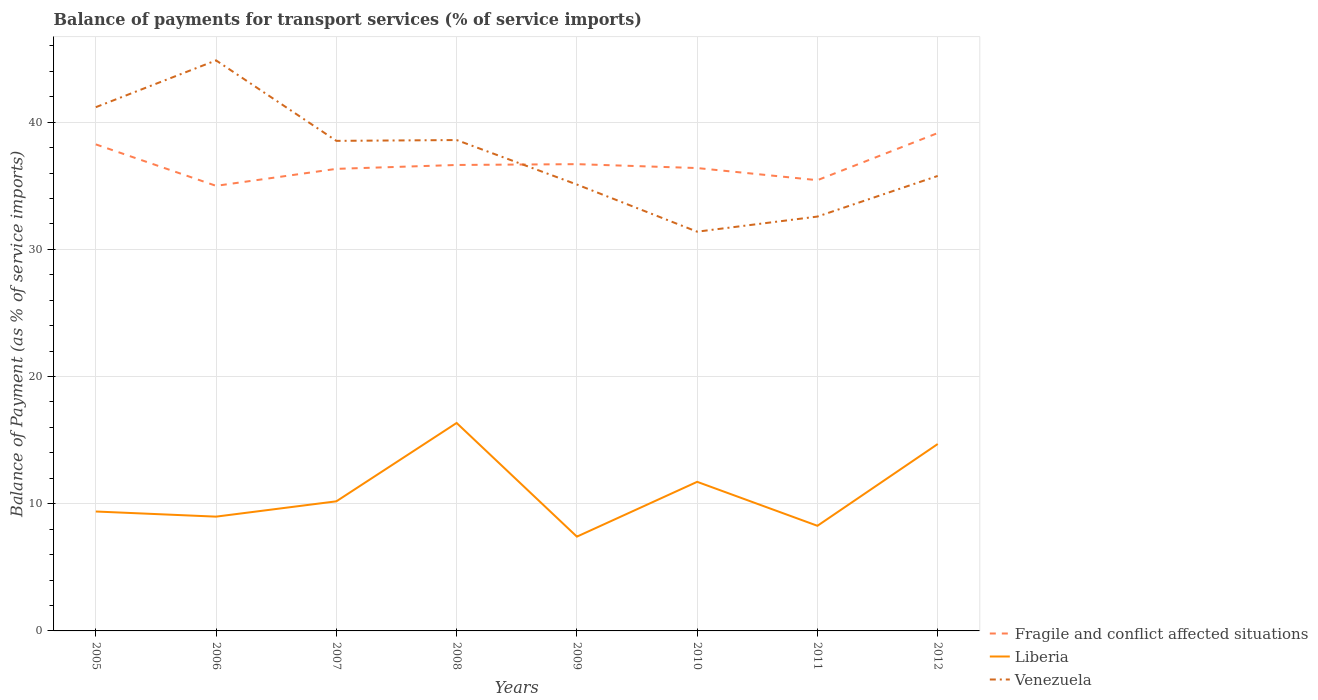How many different coloured lines are there?
Your answer should be compact. 3. Across all years, what is the maximum balance of payments for transport services in Fragile and conflict affected situations?
Give a very brief answer. 34.99. What is the total balance of payments for transport services in Liberia in the graph?
Ensure brevity in your answer.  4.63. What is the difference between the highest and the second highest balance of payments for transport services in Fragile and conflict affected situations?
Keep it short and to the point. 4.15. What is the difference between the highest and the lowest balance of payments for transport services in Liberia?
Provide a short and direct response. 3. Is the balance of payments for transport services in Liberia strictly greater than the balance of payments for transport services in Fragile and conflict affected situations over the years?
Your answer should be very brief. Yes. Are the values on the major ticks of Y-axis written in scientific E-notation?
Provide a succinct answer. No. Does the graph contain any zero values?
Your answer should be compact. No. Where does the legend appear in the graph?
Provide a succinct answer. Bottom right. How many legend labels are there?
Provide a short and direct response. 3. What is the title of the graph?
Keep it short and to the point. Balance of payments for transport services (% of service imports). Does "Uzbekistan" appear as one of the legend labels in the graph?
Make the answer very short. No. What is the label or title of the X-axis?
Offer a very short reply. Years. What is the label or title of the Y-axis?
Offer a terse response. Balance of Payment (as % of service imports). What is the Balance of Payment (as % of service imports) in Fragile and conflict affected situations in 2005?
Provide a short and direct response. 38.25. What is the Balance of Payment (as % of service imports) in Liberia in 2005?
Make the answer very short. 9.39. What is the Balance of Payment (as % of service imports) of Venezuela in 2005?
Keep it short and to the point. 41.18. What is the Balance of Payment (as % of service imports) in Fragile and conflict affected situations in 2006?
Your answer should be very brief. 34.99. What is the Balance of Payment (as % of service imports) of Liberia in 2006?
Offer a terse response. 8.99. What is the Balance of Payment (as % of service imports) in Venezuela in 2006?
Your answer should be compact. 44.86. What is the Balance of Payment (as % of service imports) of Fragile and conflict affected situations in 2007?
Ensure brevity in your answer.  36.33. What is the Balance of Payment (as % of service imports) of Liberia in 2007?
Your answer should be very brief. 10.19. What is the Balance of Payment (as % of service imports) in Venezuela in 2007?
Offer a terse response. 38.53. What is the Balance of Payment (as % of service imports) in Fragile and conflict affected situations in 2008?
Keep it short and to the point. 36.64. What is the Balance of Payment (as % of service imports) of Liberia in 2008?
Provide a succinct answer. 16.35. What is the Balance of Payment (as % of service imports) in Venezuela in 2008?
Offer a terse response. 38.59. What is the Balance of Payment (as % of service imports) in Fragile and conflict affected situations in 2009?
Offer a very short reply. 36.7. What is the Balance of Payment (as % of service imports) in Liberia in 2009?
Your response must be concise. 7.41. What is the Balance of Payment (as % of service imports) of Venezuela in 2009?
Offer a very short reply. 35.1. What is the Balance of Payment (as % of service imports) of Fragile and conflict affected situations in 2010?
Keep it short and to the point. 36.39. What is the Balance of Payment (as % of service imports) in Liberia in 2010?
Offer a very short reply. 11.72. What is the Balance of Payment (as % of service imports) in Venezuela in 2010?
Ensure brevity in your answer.  31.39. What is the Balance of Payment (as % of service imports) in Fragile and conflict affected situations in 2011?
Keep it short and to the point. 35.44. What is the Balance of Payment (as % of service imports) of Liberia in 2011?
Your answer should be compact. 8.27. What is the Balance of Payment (as % of service imports) in Venezuela in 2011?
Make the answer very short. 32.58. What is the Balance of Payment (as % of service imports) of Fragile and conflict affected situations in 2012?
Provide a short and direct response. 39.15. What is the Balance of Payment (as % of service imports) of Liberia in 2012?
Provide a short and direct response. 14.7. What is the Balance of Payment (as % of service imports) in Venezuela in 2012?
Ensure brevity in your answer.  35.77. Across all years, what is the maximum Balance of Payment (as % of service imports) of Fragile and conflict affected situations?
Your answer should be compact. 39.15. Across all years, what is the maximum Balance of Payment (as % of service imports) in Liberia?
Make the answer very short. 16.35. Across all years, what is the maximum Balance of Payment (as % of service imports) of Venezuela?
Your answer should be very brief. 44.86. Across all years, what is the minimum Balance of Payment (as % of service imports) of Fragile and conflict affected situations?
Your response must be concise. 34.99. Across all years, what is the minimum Balance of Payment (as % of service imports) in Liberia?
Your answer should be very brief. 7.41. Across all years, what is the minimum Balance of Payment (as % of service imports) in Venezuela?
Provide a succinct answer. 31.39. What is the total Balance of Payment (as % of service imports) in Fragile and conflict affected situations in the graph?
Your answer should be compact. 293.89. What is the total Balance of Payment (as % of service imports) in Liberia in the graph?
Give a very brief answer. 87.01. What is the total Balance of Payment (as % of service imports) in Venezuela in the graph?
Give a very brief answer. 298. What is the difference between the Balance of Payment (as % of service imports) of Fragile and conflict affected situations in 2005 and that in 2006?
Keep it short and to the point. 3.26. What is the difference between the Balance of Payment (as % of service imports) of Liberia in 2005 and that in 2006?
Provide a short and direct response. 0.4. What is the difference between the Balance of Payment (as % of service imports) of Venezuela in 2005 and that in 2006?
Your answer should be compact. -3.68. What is the difference between the Balance of Payment (as % of service imports) of Fragile and conflict affected situations in 2005 and that in 2007?
Offer a very short reply. 1.92. What is the difference between the Balance of Payment (as % of service imports) in Liberia in 2005 and that in 2007?
Your answer should be compact. -0.8. What is the difference between the Balance of Payment (as % of service imports) in Venezuela in 2005 and that in 2007?
Your answer should be compact. 2.65. What is the difference between the Balance of Payment (as % of service imports) in Fragile and conflict affected situations in 2005 and that in 2008?
Your answer should be compact. 1.62. What is the difference between the Balance of Payment (as % of service imports) in Liberia in 2005 and that in 2008?
Your answer should be compact. -6.96. What is the difference between the Balance of Payment (as % of service imports) in Venezuela in 2005 and that in 2008?
Offer a very short reply. 2.58. What is the difference between the Balance of Payment (as % of service imports) in Fragile and conflict affected situations in 2005 and that in 2009?
Give a very brief answer. 1.55. What is the difference between the Balance of Payment (as % of service imports) of Liberia in 2005 and that in 2009?
Your answer should be very brief. 1.98. What is the difference between the Balance of Payment (as % of service imports) of Venezuela in 2005 and that in 2009?
Give a very brief answer. 6.08. What is the difference between the Balance of Payment (as % of service imports) in Fragile and conflict affected situations in 2005 and that in 2010?
Your response must be concise. 1.86. What is the difference between the Balance of Payment (as % of service imports) of Liberia in 2005 and that in 2010?
Make the answer very short. -2.33. What is the difference between the Balance of Payment (as % of service imports) of Venezuela in 2005 and that in 2010?
Make the answer very short. 9.79. What is the difference between the Balance of Payment (as % of service imports) of Fragile and conflict affected situations in 2005 and that in 2011?
Your answer should be compact. 2.81. What is the difference between the Balance of Payment (as % of service imports) in Liberia in 2005 and that in 2011?
Your response must be concise. 1.12. What is the difference between the Balance of Payment (as % of service imports) in Venezuela in 2005 and that in 2011?
Give a very brief answer. 8.6. What is the difference between the Balance of Payment (as % of service imports) of Fragile and conflict affected situations in 2005 and that in 2012?
Your response must be concise. -0.89. What is the difference between the Balance of Payment (as % of service imports) of Liberia in 2005 and that in 2012?
Your response must be concise. -5.31. What is the difference between the Balance of Payment (as % of service imports) of Venezuela in 2005 and that in 2012?
Offer a terse response. 5.41. What is the difference between the Balance of Payment (as % of service imports) in Fragile and conflict affected situations in 2006 and that in 2007?
Your answer should be compact. -1.33. What is the difference between the Balance of Payment (as % of service imports) of Liberia in 2006 and that in 2007?
Give a very brief answer. -1.2. What is the difference between the Balance of Payment (as % of service imports) of Venezuela in 2006 and that in 2007?
Provide a short and direct response. 6.33. What is the difference between the Balance of Payment (as % of service imports) of Fragile and conflict affected situations in 2006 and that in 2008?
Offer a terse response. -1.64. What is the difference between the Balance of Payment (as % of service imports) in Liberia in 2006 and that in 2008?
Provide a succinct answer. -7.37. What is the difference between the Balance of Payment (as % of service imports) in Venezuela in 2006 and that in 2008?
Provide a succinct answer. 6.26. What is the difference between the Balance of Payment (as % of service imports) of Fragile and conflict affected situations in 2006 and that in 2009?
Offer a terse response. -1.71. What is the difference between the Balance of Payment (as % of service imports) of Liberia in 2006 and that in 2009?
Keep it short and to the point. 1.57. What is the difference between the Balance of Payment (as % of service imports) of Venezuela in 2006 and that in 2009?
Offer a terse response. 9.76. What is the difference between the Balance of Payment (as % of service imports) of Fragile and conflict affected situations in 2006 and that in 2010?
Your response must be concise. -1.4. What is the difference between the Balance of Payment (as % of service imports) in Liberia in 2006 and that in 2010?
Offer a very short reply. -2.74. What is the difference between the Balance of Payment (as % of service imports) of Venezuela in 2006 and that in 2010?
Your response must be concise. 13.47. What is the difference between the Balance of Payment (as % of service imports) in Fragile and conflict affected situations in 2006 and that in 2011?
Ensure brevity in your answer.  -0.45. What is the difference between the Balance of Payment (as % of service imports) in Liberia in 2006 and that in 2011?
Your answer should be compact. 0.72. What is the difference between the Balance of Payment (as % of service imports) of Venezuela in 2006 and that in 2011?
Your answer should be very brief. 12.28. What is the difference between the Balance of Payment (as % of service imports) of Fragile and conflict affected situations in 2006 and that in 2012?
Offer a terse response. -4.15. What is the difference between the Balance of Payment (as % of service imports) of Liberia in 2006 and that in 2012?
Keep it short and to the point. -5.71. What is the difference between the Balance of Payment (as % of service imports) of Venezuela in 2006 and that in 2012?
Provide a short and direct response. 9.08. What is the difference between the Balance of Payment (as % of service imports) in Fragile and conflict affected situations in 2007 and that in 2008?
Your answer should be very brief. -0.31. What is the difference between the Balance of Payment (as % of service imports) in Liberia in 2007 and that in 2008?
Provide a short and direct response. -6.16. What is the difference between the Balance of Payment (as % of service imports) in Venezuela in 2007 and that in 2008?
Give a very brief answer. -0.06. What is the difference between the Balance of Payment (as % of service imports) of Fragile and conflict affected situations in 2007 and that in 2009?
Give a very brief answer. -0.37. What is the difference between the Balance of Payment (as % of service imports) of Liberia in 2007 and that in 2009?
Make the answer very short. 2.78. What is the difference between the Balance of Payment (as % of service imports) of Venezuela in 2007 and that in 2009?
Ensure brevity in your answer.  3.43. What is the difference between the Balance of Payment (as % of service imports) in Fragile and conflict affected situations in 2007 and that in 2010?
Offer a terse response. -0.06. What is the difference between the Balance of Payment (as % of service imports) in Liberia in 2007 and that in 2010?
Provide a succinct answer. -1.53. What is the difference between the Balance of Payment (as % of service imports) of Venezuela in 2007 and that in 2010?
Provide a succinct answer. 7.14. What is the difference between the Balance of Payment (as % of service imports) in Fragile and conflict affected situations in 2007 and that in 2011?
Provide a short and direct response. 0.89. What is the difference between the Balance of Payment (as % of service imports) in Liberia in 2007 and that in 2011?
Your answer should be very brief. 1.92. What is the difference between the Balance of Payment (as % of service imports) of Venezuela in 2007 and that in 2011?
Give a very brief answer. 5.95. What is the difference between the Balance of Payment (as % of service imports) in Fragile and conflict affected situations in 2007 and that in 2012?
Offer a terse response. -2.82. What is the difference between the Balance of Payment (as % of service imports) in Liberia in 2007 and that in 2012?
Give a very brief answer. -4.51. What is the difference between the Balance of Payment (as % of service imports) of Venezuela in 2007 and that in 2012?
Provide a succinct answer. 2.76. What is the difference between the Balance of Payment (as % of service imports) of Fragile and conflict affected situations in 2008 and that in 2009?
Make the answer very short. -0.07. What is the difference between the Balance of Payment (as % of service imports) in Liberia in 2008 and that in 2009?
Make the answer very short. 8.94. What is the difference between the Balance of Payment (as % of service imports) of Venezuela in 2008 and that in 2009?
Ensure brevity in your answer.  3.5. What is the difference between the Balance of Payment (as % of service imports) of Fragile and conflict affected situations in 2008 and that in 2010?
Your answer should be very brief. 0.24. What is the difference between the Balance of Payment (as % of service imports) of Liberia in 2008 and that in 2010?
Make the answer very short. 4.63. What is the difference between the Balance of Payment (as % of service imports) of Venezuela in 2008 and that in 2010?
Offer a terse response. 7.21. What is the difference between the Balance of Payment (as % of service imports) of Fragile and conflict affected situations in 2008 and that in 2011?
Your response must be concise. 1.2. What is the difference between the Balance of Payment (as % of service imports) in Liberia in 2008 and that in 2011?
Provide a succinct answer. 8.09. What is the difference between the Balance of Payment (as % of service imports) in Venezuela in 2008 and that in 2011?
Your answer should be very brief. 6.02. What is the difference between the Balance of Payment (as % of service imports) of Fragile and conflict affected situations in 2008 and that in 2012?
Keep it short and to the point. -2.51. What is the difference between the Balance of Payment (as % of service imports) of Liberia in 2008 and that in 2012?
Make the answer very short. 1.66. What is the difference between the Balance of Payment (as % of service imports) in Venezuela in 2008 and that in 2012?
Provide a short and direct response. 2.82. What is the difference between the Balance of Payment (as % of service imports) in Fragile and conflict affected situations in 2009 and that in 2010?
Keep it short and to the point. 0.31. What is the difference between the Balance of Payment (as % of service imports) of Liberia in 2009 and that in 2010?
Offer a very short reply. -4.31. What is the difference between the Balance of Payment (as % of service imports) of Venezuela in 2009 and that in 2010?
Provide a succinct answer. 3.71. What is the difference between the Balance of Payment (as % of service imports) in Fragile and conflict affected situations in 2009 and that in 2011?
Provide a short and direct response. 1.26. What is the difference between the Balance of Payment (as % of service imports) in Liberia in 2009 and that in 2011?
Ensure brevity in your answer.  -0.85. What is the difference between the Balance of Payment (as % of service imports) in Venezuela in 2009 and that in 2011?
Give a very brief answer. 2.52. What is the difference between the Balance of Payment (as % of service imports) in Fragile and conflict affected situations in 2009 and that in 2012?
Your response must be concise. -2.45. What is the difference between the Balance of Payment (as % of service imports) in Liberia in 2009 and that in 2012?
Your answer should be very brief. -7.28. What is the difference between the Balance of Payment (as % of service imports) of Venezuela in 2009 and that in 2012?
Your response must be concise. -0.68. What is the difference between the Balance of Payment (as % of service imports) of Fragile and conflict affected situations in 2010 and that in 2011?
Provide a succinct answer. 0.95. What is the difference between the Balance of Payment (as % of service imports) of Liberia in 2010 and that in 2011?
Make the answer very short. 3.46. What is the difference between the Balance of Payment (as % of service imports) of Venezuela in 2010 and that in 2011?
Provide a short and direct response. -1.19. What is the difference between the Balance of Payment (as % of service imports) in Fragile and conflict affected situations in 2010 and that in 2012?
Make the answer very short. -2.75. What is the difference between the Balance of Payment (as % of service imports) in Liberia in 2010 and that in 2012?
Offer a terse response. -2.97. What is the difference between the Balance of Payment (as % of service imports) of Venezuela in 2010 and that in 2012?
Your answer should be very brief. -4.38. What is the difference between the Balance of Payment (as % of service imports) in Fragile and conflict affected situations in 2011 and that in 2012?
Your answer should be very brief. -3.71. What is the difference between the Balance of Payment (as % of service imports) in Liberia in 2011 and that in 2012?
Your response must be concise. -6.43. What is the difference between the Balance of Payment (as % of service imports) in Venezuela in 2011 and that in 2012?
Offer a terse response. -3.19. What is the difference between the Balance of Payment (as % of service imports) in Fragile and conflict affected situations in 2005 and the Balance of Payment (as % of service imports) in Liberia in 2006?
Your answer should be compact. 29.27. What is the difference between the Balance of Payment (as % of service imports) in Fragile and conflict affected situations in 2005 and the Balance of Payment (as % of service imports) in Venezuela in 2006?
Make the answer very short. -6.6. What is the difference between the Balance of Payment (as % of service imports) of Liberia in 2005 and the Balance of Payment (as % of service imports) of Venezuela in 2006?
Give a very brief answer. -35.47. What is the difference between the Balance of Payment (as % of service imports) of Fragile and conflict affected situations in 2005 and the Balance of Payment (as % of service imports) of Liberia in 2007?
Ensure brevity in your answer.  28.06. What is the difference between the Balance of Payment (as % of service imports) in Fragile and conflict affected situations in 2005 and the Balance of Payment (as % of service imports) in Venezuela in 2007?
Your response must be concise. -0.28. What is the difference between the Balance of Payment (as % of service imports) in Liberia in 2005 and the Balance of Payment (as % of service imports) in Venezuela in 2007?
Provide a succinct answer. -29.14. What is the difference between the Balance of Payment (as % of service imports) in Fragile and conflict affected situations in 2005 and the Balance of Payment (as % of service imports) in Liberia in 2008?
Offer a terse response. 21.9. What is the difference between the Balance of Payment (as % of service imports) of Fragile and conflict affected situations in 2005 and the Balance of Payment (as % of service imports) of Venezuela in 2008?
Give a very brief answer. -0.34. What is the difference between the Balance of Payment (as % of service imports) of Liberia in 2005 and the Balance of Payment (as % of service imports) of Venezuela in 2008?
Offer a very short reply. -29.21. What is the difference between the Balance of Payment (as % of service imports) of Fragile and conflict affected situations in 2005 and the Balance of Payment (as % of service imports) of Liberia in 2009?
Offer a very short reply. 30.84. What is the difference between the Balance of Payment (as % of service imports) in Fragile and conflict affected situations in 2005 and the Balance of Payment (as % of service imports) in Venezuela in 2009?
Keep it short and to the point. 3.16. What is the difference between the Balance of Payment (as % of service imports) of Liberia in 2005 and the Balance of Payment (as % of service imports) of Venezuela in 2009?
Offer a very short reply. -25.71. What is the difference between the Balance of Payment (as % of service imports) in Fragile and conflict affected situations in 2005 and the Balance of Payment (as % of service imports) in Liberia in 2010?
Your answer should be compact. 26.53. What is the difference between the Balance of Payment (as % of service imports) of Fragile and conflict affected situations in 2005 and the Balance of Payment (as % of service imports) of Venezuela in 2010?
Keep it short and to the point. 6.86. What is the difference between the Balance of Payment (as % of service imports) in Liberia in 2005 and the Balance of Payment (as % of service imports) in Venezuela in 2010?
Your answer should be compact. -22. What is the difference between the Balance of Payment (as % of service imports) of Fragile and conflict affected situations in 2005 and the Balance of Payment (as % of service imports) of Liberia in 2011?
Your response must be concise. 29.99. What is the difference between the Balance of Payment (as % of service imports) of Fragile and conflict affected situations in 2005 and the Balance of Payment (as % of service imports) of Venezuela in 2011?
Give a very brief answer. 5.68. What is the difference between the Balance of Payment (as % of service imports) of Liberia in 2005 and the Balance of Payment (as % of service imports) of Venezuela in 2011?
Offer a terse response. -23.19. What is the difference between the Balance of Payment (as % of service imports) in Fragile and conflict affected situations in 2005 and the Balance of Payment (as % of service imports) in Liberia in 2012?
Your answer should be compact. 23.56. What is the difference between the Balance of Payment (as % of service imports) in Fragile and conflict affected situations in 2005 and the Balance of Payment (as % of service imports) in Venezuela in 2012?
Ensure brevity in your answer.  2.48. What is the difference between the Balance of Payment (as % of service imports) in Liberia in 2005 and the Balance of Payment (as % of service imports) in Venezuela in 2012?
Make the answer very short. -26.38. What is the difference between the Balance of Payment (as % of service imports) in Fragile and conflict affected situations in 2006 and the Balance of Payment (as % of service imports) in Liberia in 2007?
Make the answer very short. 24.8. What is the difference between the Balance of Payment (as % of service imports) of Fragile and conflict affected situations in 2006 and the Balance of Payment (as % of service imports) of Venezuela in 2007?
Your answer should be compact. -3.54. What is the difference between the Balance of Payment (as % of service imports) in Liberia in 2006 and the Balance of Payment (as % of service imports) in Venezuela in 2007?
Keep it short and to the point. -29.55. What is the difference between the Balance of Payment (as % of service imports) in Fragile and conflict affected situations in 2006 and the Balance of Payment (as % of service imports) in Liberia in 2008?
Your response must be concise. 18.64. What is the difference between the Balance of Payment (as % of service imports) in Fragile and conflict affected situations in 2006 and the Balance of Payment (as % of service imports) in Venezuela in 2008?
Give a very brief answer. -3.6. What is the difference between the Balance of Payment (as % of service imports) of Liberia in 2006 and the Balance of Payment (as % of service imports) of Venezuela in 2008?
Provide a short and direct response. -29.61. What is the difference between the Balance of Payment (as % of service imports) in Fragile and conflict affected situations in 2006 and the Balance of Payment (as % of service imports) in Liberia in 2009?
Ensure brevity in your answer.  27.58. What is the difference between the Balance of Payment (as % of service imports) in Fragile and conflict affected situations in 2006 and the Balance of Payment (as % of service imports) in Venezuela in 2009?
Make the answer very short. -0.1. What is the difference between the Balance of Payment (as % of service imports) of Liberia in 2006 and the Balance of Payment (as % of service imports) of Venezuela in 2009?
Make the answer very short. -26.11. What is the difference between the Balance of Payment (as % of service imports) in Fragile and conflict affected situations in 2006 and the Balance of Payment (as % of service imports) in Liberia in 2010?
Your response must be concise. 23.27. What is the difference between the Balance of Payment (as % of service imports) of Fragile and conflict affected situations in 2006 and the Balance of Payment (as % of service imports) of Venezuela in 2010?
Your answer should be compact. 3.6. What is the difference between the Balance of Payment (as % of service imports) in Liberia in 2006 and the Balance of Payment (as % of service imports) in Venezuela in 2010?
Offer a terse response. -22.4. What is the difference between the Balance of Payment (as % of service imports) in Fragile and conflict affected situations in 2006 and the Balance of Payment (as % of service imports) in Liberia in 2011?
Your response must be concise. 26.73. What is the difference between the Balance of Payment (as % of service imports) of Fragile and conflict affected situations in 2006 and the Balance of Payment (as % of service imports) of Venezuela in 2011?
Keep it short and to the point. 2.42. What is the difference between the Balance of Payment (as % of service imports) in Liberia in 2006 and the Balance of Payment (as % of service imports) in Venezuela in 2011?
Make the answer very short. -23.59. What is the difference between the Balance of Payment (as % of service imports) of Fragile and conflict affected situations in 2006 and the Balance of Payment (as % of service imports) of Liberia in 2012?
Your answer should be very brief. 20.3. What is the difference between the Balance of Payment (as % of service imports) of Fragile and conflict affected situations in 2006 and the Balance of Payment (as % of service imports) of Venezuela in 2012?
Keep it short and to the point. -0.78. What is the difference between the Balance of Payment (as % of service imports) in Liberia in 2006 and the Balance of Payment (as % of service imports) in Venezuela in 2012?
Make the answer very short. -26.79. What is the difference between the Balance of Payment (as % of service imports) of Fragile and conflict affected situations in 2007 and the Balance of Payment (as % of service imports) of Liberia in 2008?
Your answer should be compact. 19.98. What is the difference between the Balance of Payment (as % of service imports) in Fragile and conflict affected situations in 2007 and the Balance of Payment (as % of service imports) in Venezuela in 2008?
Keep it short and to the point. -2.27. What is the difference between the Balance of Payment (as % of service imports) of Liberia in 2007 and the Balance of Payment (as % of service imports) of Venezuela in 2008?
Give a very brief answer. -28.41. What is the difference between the Balance of Payment (as % of service imports) in Fragile and conflict affected situations in 2007 and the Balance of Payment (as % of service imports) in Liberia in 2009?
Make the answer very short. 28.92. What is the difference between the Balance of Payment (as % of service imports) in Fragile and conflict affected situations in 2007 and the Balance of Payment (as % of service imports) in Venezuela in 2009?
Offer a terse response. 1.23. What is the difference between the Balance of Payment (as % of service imports) in Liberia in 2007 and the Balance of Payment (as % of service imports) in Venezuela in 2009?
Your answer should be compact. -24.91. What is the difference between the Balance of Payment (as % of service imports) in Fragile and conflict affected situations in 2007 and the Balance of Payment (as % of service imports) in Liberia in 2010?
Your answer should be very brief. 24.61. What is the difference between the Balance of Payment (as % of service imports) in Fragile and conflict affected situations in 2007 and the Balance of Payment (as % of service imports) in Venezuela in 2010?
Your response must be concise. 4.94. What is the difference between the Balance of Payment (as % of service imports) in Liberia in 2007 and the Balance of Payment (as % of service imports) in Venezuela in 2010?
Make the answer very short. -21.2. What is the difference between the Balance of Payment (as % of service imports) of Fragile and conflict affected situations in 2007 and the Balance of Payment (as % of service imports) of Liberia in 2011?
Offer a terse response. 28.06. What is the difference between the Balance of Payment (as % of service imports) in Fragile and conflict affected situations in 2007 and the Balance of Payment (as % of service imports) in Venezuela in 2011?
Provide a short and direct response. 3.75. What is the difference between the Balance of Payment (as % of service imports) of Liberia in 2007 and the Balance of Payment (as % of service imports) of Venezuela in 2011?
Your answer should be compact. -22.39. What is the difference between the Balance of Payment (as % of service imports) of Fragile and conflict affected situations in 2007 and the Balance of Payment (as % of service imports) of Liberia in 2012?
Keep it short and to the point. 21.63. What is the difference between the Balance of Payment (as % of service imports) in Fragile and conflict affected situations in 2007 and the Balance of Payment (as % of service imports) in Venezuela in 2012?
Offer a terse response. 0.56. What is the difference between the Balance of Payment (as % of service imports) of Liberia in 2007 and the Balance of Payment (as % of service imports) of Venezuela in 2012?
Keep it short and to the point. -25.58. What is the difference between the Balance of Payment (as % of service imports) in Fragile and conflict affected situations in 2008 and the Balance of Payment (as % of service imports) in Liberia in 2009?
Your answer should be very brief. 29.22. What is the difference between the Balance of Payment (as % of service imports) of Fragile and conflict affected situations in 2008 and the Balance of Payment (as % of service imports) of Venezuela in 2009?
Keep it short and to the point. 1.54. What is the difference between the Balance of Payment (as % of service imports) in Liberia in 2008 and the Balance of Payment (as % of service imports) in Venezuela in 2009?
Make the answer very short. -18.75. What is the difference between the Balance of Payment (as % of service imports) in Fragile and conflict affected situations in 2008 and the Balance of Payment (as % of service imports) in Liberia in 2010?
Your answer should be very brief. 24.91. What is the difference between the Balance of Payment (as % of service imports) of Fragile and conflict affected situations in 2008 and the Balance of Payment (as % of service imports) of Venezuela in 2010?
Keep it short and to the point. 5.25. What is the difference between the Balance of Payment (as % of service imports) in Liberia in 2008 and the Balance of Payment (as % of service imports) in Venezuela in 2010?
Offer a terse response. -15.04. What is the difference between the Balance of Payment (as % of service imports) in Fragile and conflict affected situations in 2008 and the Balance of Payment (as % of service imports) in Liberia in 2011?
Provide a short and direct response. 28.37. What is the difference between the Balance of Payment (as % of service imports) of Fragile and conflict affected situations in 2008 and the Balance of Payment (as % of service imports) of Venezuela in 2011?
Keep it short and to the point. 4.06. What is the difference between the Balance of Payment (as % of service imports) in Liberia in 2008 and the Balance of Payment (as % of service imports) in Venezuela in 2011?
Offer a very short reply. -16.23. What is the difference between the Balance of Payment (as % of service imports) in Fragile and conflict affected situations in 2008 and the Balance of Payment (as % of service imports) in Liberia in 2012?
Offer a terse response. 21.94. What is the difference between the Balance of Payment (as % of service imports) in Fragile and conflict affected situations in 2008 and the Balance of Payment (as % of service imports) in Venezuela in 2012?
Your answer should be very brief. 0.86. What is the difference between the Balance of Payment (as % of service imports) of Liberia in 2008 and the Balance of Payment (as % of service imports) of Venezuela in 2012?
Make the answer very short. -19.42. What is the difference between the Balance of Payment (as % of service imports) in Fragile and conflict affected situations in 2009 and the Balance of Payment (as % of service imports) in Liberia in 2010?
Offer a very short reply. 24.98. What is the difference between the Balance of Payment (as % of service imports) of Fragile and conflict affected situations in 2009 and the Balance of Payment (as % of service imports) of Venezuela in 2010?
Your answer should be compact. 5.31. What is the difference between the Balance of Payment (as % of service imports) of Liberia in 2009 and the Balance of Payment (as % of service imports) of Venezuela in 2010?
Ensure brevity in your answer.  -23.98. What is the difference between the Balance of Payment (as % of service imports) of Fragile and conflict affected situations in 2009 and the Balance of Payment (as % of service imports) of Liberia in 2011?
Provide a short and direct response. 28.44. What is the difference between the Balance of Payment (as % of service imports) in Fragile and conflict affected situations in 2009 and the Balance of Payment (as % of service imports) in Venezuela in 2011?
Give a very brief answer. 4.12. What is the difference between the Balance of Payment (as % of service imports) in Liberia in 2009 and the Balance of Payment (as % of service imports) in Venezuela in 2011?
Your answer should be very brief. -25.17. What is the difference between the Balance of Payment (as % of service imports) in Fragile and conflict affected situations in 2009 and the Balance of Payment (as % of service imports) in Liberia in 2012?
Make the answer very short. 22. What is the difference between the Balance of Payment (as % of service imports) in Fragile and conflict affected situations in 2009 and the Balance of Payment (as % of service imports) in Venezuela in 2012?
Keep it short and to the point. 0.93. What is the difference between the Balance of Payment (as % of service imports) of Liberia in 2009 and the Balance of Payment (as % of service imports) of Venezuela in 2012?
Provide a short and direct response. -28.36. What is the difference between the Balance of Payment (as % of service imports) of Fragile and conflict affected situations in 2010 and the Balance of Payment (as % of service imports) of Liberia in 2011?
Provide a succinct answer. 28.13. What is the difference between the Balance of Payment (as % of service imports) of Fragile and conflict affected situations in 2010 and the Balance of Payment (as % of service imports) of Venezuela in 2011?
Your answer should be compact. 3.81. What is the difference between the Balance of Payment (as % of service imports) in Liberia in 2010 and the Balance of Payment (as % of service imports) in Venezuela in 2011?
Offer a terse response. -20.86. What is the difference between the Balance of Payment (as % of service imports) in Fragile and conflict affected situations in 2010 and the Balance of Payment (as % of service imports) in Liberia in 2012?
Ensure brevity in your answer.  21.7. What is the difference between the Balance of Payment (as % of service imports) in Fragile and conflict affected situations in 2010 and the Balance of Payment (as % of service imports) in Venezuela in 2012?
Provide a short and direct response. 0.62. What is the difference between the Balance of Payment (as % of service imports) of Liberia in 2010 and the Balance of Payment (as % of service imports) of Venezuela in 2012?
Keep it short and to the point. -24.05. What is the difference between the Balance of Payment (as % of service imports) in Fragile and conflict affected situations in 2011 and the Balance of Payment (as % of service imports) in Liberia in 2012?
Your answer should be very brief. 20.74. What is the difference between the Balance of Payment (as % of service imports) in Fragile and conflict affected situations in 2011 and the Balance of Payment (as % of service imports) in Venezuela in 2012?
Keep it short and to the point. -0.33. What is the difference between the Balance of Payment (as % of service imports) in Liberia in 2011 and the Balance of Payment (as % of service imports) in Venezuela in 2012?
Your answer should be very brief. -27.51. What is the average Balance of Payment (as % of service imports) in Fragile and conflict affected situations per year?
Offer a very short reply. 36.74. What is the average Balance of Payment (as % of service imports) of Liberia per year?
Your answer should be compact. 10.88. What is the average Balance of Payment (as % of service imports) in Venezuela per year?
Give a very brief answer. 37.25. In the year 2005, what is the difference between the Balance of Payment (as % of service imports) of Fragile and conflict affected situations and Balance of Payment (as % of service imports) of Liberia?
Provide a succinct answer. 28.87. In the year 2005, what is the difference between the Balance of Payment (as % of service imports) of Fragile and conflict affected situations and Balance of Payment (as % of service imports) of Venezuela?
Provide a short and direct response. -2.92. In the year 2005, what is the difference between the Balance of Payment (as % of service imports) of Liberia and Balance of Payment (as % of service imports) of Venezuela?
Offer a terse response. -31.79. In the year 2006, what is the difference between the Balance of Payment (as % of service imports) in Fragile and conflict affected situations and Balance of Payment (as % of service imports) in Liberia?
Make the answer very short. 26.01. In the year 2006, what is the difference between the Balance of Payment (as % of service imports) in Fragile and conflict affected situations and Balance of Payment (as % of service imports) in Venezuela?
Give a very brief answer. -9.86. In the year 2006, what is the difference between the Balance of Payment (as % of service imports) of Liberia and Balance of Payment (as % of service imports) of Venezuela?
Your response must be concise. -35.87. In the year 2007, what is the difference between the Balance of Payment (as % of service imports) of Fragile and conflict affected situations and Balance of Payment (as % of service imports) of Liberia?
Ensure brevity in your answer.  26.14. In the year 2007, what is the difference between the Balance of Payment (as % of service imports) of Fragile and conflict affected situations and Balance of Payment (as % of service imports) of Venezuela?
Provide a short and direct response. -2.2. In the year 2007, what is the difference between the Balance of Payment (as % of service imports) in Liberia and Balance of Payment (as % of service imports) in Venezuela?
Your response must be concise. -28.34. In the year 2008, what is the difference between the Balance of Payment (as % of service imports) in Fragile and conflict affected situations and Balance of Payment (as % of service imports) in Liberia?
Provide a succinct answer. 20.28. In the year 2008, what is the difference between the Balance of Payment (as % of service imports) in Fragile and conflict affected situations and Balance of Payment (as % of service imports) in Venezuela?
Your response must be concise. -1.96. In the year 2008, what is the difference between the Balance of Payment (as % of service imports) in Liberia and Balance of Payment (as % of service imports) in Venezuela?
Your answer should be compact. -22.24. In the year 2009, what is the difference between the Balance of Payment (as % of service imports) of Fragile and conflict affected situations and Balance of Payment (as % of service imports) of Liberia?
Provide a succinct answer. 29.29. In the year 2009, what is the difference between the Balance of Payment (as % of service imports) in Fragile and conflict affected situations and Balance of Payment (as % of service imports) in Venezuela?
Offer a terse response. 1.6. In the year 2009, what is the difference between the Balance of Payment (as % of service imports) of Liberia and Balance of Payment (as % of service imports) of Venezuela?
Your answer should be very brief. -27.69. In the year 2010, what is the difference between the Balance of Payment (as % of service imports) of Fragile and conflict affected situations and Balance of Payment (as % of service imports) of Liberia?
Ensure brevity in your answer.  24.67. In the year 2010, what is the difference between the Balance of Payment (as % of service imports) in Fragile and conflict affected situations and Balance of Payment (as % of service imports) in Venezuela?
Your response must be concise. 5. In the year 2010, what is the difference between the Balance of Payment (as % of service imports) in Liberia and Balance of Payment (as % of service imports) in Venezuela?
Provide a short and direct response. -19.67. In the year 2011, what is the difference between the Balance of Payment (as % of service imports) in Fragile and conflict affected situations and Balance of Payment (as % of service imports) in Liberia?
Your answer should be compact. 27.17. In the year 2011, what is the difference between the Balance of Payment (as % of service imports) in Fragile and conflict affected situations and Balance of Payment (as % of service imports) in Venezuela?
Ensure brevity in your answer.  2.86. In the year 2011, what is the difference between the Balance of Payment (as % of service imports) of Liberia and Balance of Payment (as % of service imports) of Venezuela?
Your answer should be very brief. -24.31. In the year 2012, what is the difference between the Balance of Payment (as % of service imports) of Fragile and conflict affected situations and Balance of Payment (as % of service imports) of Liberia?
Provide a succinct answer. 24.45. In the year 2012, what is the difference between the Balance of Payment (as % of service imports) of Fragile and conflict affected situations and Balance of Payment (as % of service imports) of Venezuela?
Provide a short and direct response. 3.37. In the year 2012, what is the difference between the Balance of Payment (as % of service imports) of Liberia and Balance of Payment (as % of service imports) of Venezuela?
Offer a very short reply. -21.08. What is the ratio of the Balance of Payment (as % of service imports) of Fragile and conflict affected situations in 2005 to that in 2006?
Your answer should be very brief. 1.09. What is the ratio of the Balance of Payment (as % of service imports) of Liberia in 2005 to that in 2006?
Your answer should be compact. 1.04. What is the ratio of the Balance of Payment (as % of service imports) in Venezuela in 2005 to that in 2006?
Keep it short and to the point. 0.92. What is the ratio of the Balance of Payment (as % of service imports) of Fragile and conflict affected situations in 2005 to that in 2007?
Offer a very short reply. 1.05. What is the ratio of the Balance of Payment (as % of service imports) in Liberia in 2005 to that in 2007?
Keep it short and to the point. 0.92. What is the ratio of the Balance of Payment (as % of service imports) in Venezuela in 2005 to that in 2007?
Make the answer very short. 1.07. What is the ratio of the Balance of Payment (as % of service imports) in Fragile and conflict affected situations in 2005 to that in 2008?
Your answer should be compact. 1.04. What is the ratio of the Balance of Payment (as % of service imports) in Liberia in 2005 to that in 2008?
Your answer should be very brief. 0.57. What is the ratio of the Balance of Payment (as % of service imports) of Venezuela in 2005 to that in 2008?
Provide a short and direct response. 1.07. What is the ratio of the Balance of Payment (as % of service imports) in Fragile and conflict affected situations in 2005 to that in 2009?
Offer a very short reply. 1.04. What is the ratio of the Balance of Payment (as % of service imports) in Liberia in 2005 to that in 2009?
Give a very brief answer. 1.27. What is the ratio of the Balance of Payment (as % of service imports) in Venezuela in 2005 to that in 2009?
Keep it short and to the point. 1.17. What is the ratio of the Balance of Payment (as % of service imports) of Fragile and conflict affected situations in 2005 to that in 2010?
Provide a short and direct response. 1.05. What is the ratio of the Balance of Payment (as % of service imports) in Liberia in 2005 to that in 2010?
Make the answer very short. 0.8. What is the ratio of the Balance of Payment (as % of service imports) of Venezuela in 2005 to that in 2010?
Provide a short and direct response. 1.31. What is the ratio of the Balance of Payment (as % of service imports) of Fragile and conflict affected situations in 2005 to that in 2011?
Your response must be concise. 1.08. What is the ratio of the Balance of Payment (as % of service imports) of Liberia in 2005 to that in 2011?
Ensure brevity in your answer.  1.14. What is the ratio of the Balance of Payment (as % of service imports) of Venezuela in 2005 to that in 2011?
Offer a terse response. 1.26. What is the ratio of the Balance of Payment (as % of service imports) of Fragile and conflict affected situations in 2005 to that in 2012?
Offer a terse response. 0.98. What is the ratio of the Balance of Payment (as % of service imports) of Liberia in 2005 to that in 2012?
Give a very brief answer. 0.64. What is the ratio of the Balance of Payment (as % of service imports) in Venezuela in 2005 to that in 2012?
Offer a terse response. 1.15. What is the ratio of the Balance of Payment (as % of service imports) of Fragile and conflict affected situations in 2006 to that in 2007?
Your answer should be compact. 0.96. What is the ratio of the Balance of Payment (as % of service imports) in Liberia in 2006 to that in 2007?
Ensure brevity in your answer.  0.88. What is the ratio of the Balance of Payment (as % of service imports) of Venezuela in 2006 to that in 2007?
Provide a short and direct response. 1.16. What is the ratio of the Balance of Payment (as % of service imports) in Fragile and conflict affected situations in 2006 to that in 2008?
Offer a terse response. 0.96. What is the ratio of the Balance of Payment (as % of service imports) of Liberia in 2006 to that in 2008?
Offer a very short reply. 0.55. What is the ratio of the Balance of Payment (as % of service imports) of Venezuela in 2006 to that in 2008?
Ensure brevity in your answer.  1.16. What is the ratio of the Balance of Payment (as % of service imports) in Fragile and conflict affected situations in 2006 to that in 2009?
Provide a succinct answer. 0.95. What is the ratio of the Balance of Payment (as % of service imports) of Liberia in 2006 to that in 2009?
Provide a succinct answer. 1.21. What is the ratio of the Balance of Payment (as % of service imports) of Venezuela in 2006 to that in 2009?
Your response must be concise. 1.28. What is the ratio of the Balance of Payment (as % of service imports) of Fragile and conflict affected situations in 2006 to that in 2010?
Keep it short and to the point. 0.96. What is the ratio of the Balance of Payment (as % of service imports) of Liberia in 2006 to that in 2010?
Offer a very short reply. 0.77. What is the ratio of the Balance of Payment (as % of service imports) of Venezuela in 2006 to that in 2010?
Ensure brevity in your answer.  1.43. What is the ratio of the Balance of Payment (as % of service imports) in Fragile and conflict affected situations in 2006 to that in 2011?
Provide a short and direct response. 0.99. What is the ratio of the Balance of Payment (as % of service imports) in Liberia in 2006 to that in 2011?
Provide a succinct answer. 1.09. What is the ratio of the Balance of Payment (as % of service imports) of Venezuela in 2006 to that in 2011?
Provide a succinct answer. 1.38. What is the ratio of the Balance of Payment (as % of service imports) of Fragile and conflict affected situations in 2006 to that in 2012?
Your answer should be compact. 0.89. What is the ratio of the Balance of Payment (as % of service imports) of Liberia in 2006 to that in 2012?
Provide a short and direct response. 0.61. What is the ratio of the Balance of Payment (as % of service imports) of Venezuela in 2006 to that in 2012?
Your answer should be compact. 1.25. What is the ratio of the Balance of Payment (as % of service imports) of Liberia in 2007 to that in 2008?
Ensure brevity in your answer.  0.62. What is the ratio of the Balance of Payment (as % of service imports) of Fragile and conflict affected situations in 2007 to that in 2009?
Give a very brief answer. 0.99. What is the ratio of the Balance of Payment (as % of service imports) of Liberia in 2007 to that in 2009?
Make the answer very short. 1.37. What is the ratio of the Balance of Payment (as % of service imports) in Venezuela in 2007 to that in 2009?
Your answer should be compact. 1.1. What is the ratio of the Balance of Payment (as % of service imports) of Liberia in 2007 to that in 2010?
Your response must be concise. 0.87. What is the ratio of the Balance of Payment (as % of service imports) in Venezuela in 2007 to that in 2010?
Keep it short and to the point. 1.23. What is the ratio of the Balance of Payment (as % of service imports) of Fragile and conflict affected situations in 2007 to that in 2011?
Your answer should be very brief. 1.03. What is the ratio of the Balance of Payment (as % of service imports) in Liberia in 2007 to that in 2011?
Your answer should be compact. 1.23. What is the ratio of the Balance of Payment (as % of service imports) in Venezuela in 2007 to that in 2011?
Offer a terse response. 1.18. What is the ratio of the Balance of Payment (as % of service imports) in Fragile and conflict affected situations in 2007 to that in 2012?
Ensure brevity in your answer.  0.93. What is the ratio of the Balance of Payment (as % of service imports) in Liberia in 2007 to that in 2012?
Provide a short and direct response. 0.69. What is the ratio of the Balance of Payment (as % of service imports) of Venezuela in 2007 to that in 2012?
Provide a succinct answer. 1.08. What is the ratio of the Balance of Payment (as % of service imports) of Fragile and conflict affected situations in 2008 to that in 2009?
Your answer should be compact. 1. What is the ratio of the Balance of Payment (as % of service imports) in Liberia in 2008 to that in 2009?
Offer a terse response. 2.21. What is the ratio of the Balance of Payment (as % of service imports) in Venezuela in 2008 to that in 2009?
Provide a succinct answer. 1.1. What is the ratio of the Balance of Payment (as % of service imports) in Fragile and conflict affected situations in 2008 to that in 2010?
Ensure brevity in your answer.  1.01. What is the ratio of the Balance of Payment (as % of service imports) in Liberia in 2008 to that in 2010?
Offer a very short reply. 1.39. What is the ratio of the Balance of Payment (as % of service imports) of Venezuela in 2008 to that in 2010?
Make the answer very short. 1.23. What is the ratio of the Balance of Payment (as % of service imports) in Fragile and conflict affected situations in 2008 to that in 2011?
Provide a succinct answer. 1.03. What is the ratio of the Balance of Payment (as % of service imports) in Liberia in 2008 to that in 2011?
Make the answer very short. 1.98. What is the ratio of the Balance of Payment (as % of service imports) in Venezuela in 2008 to that in 2011?
Your answer should be compact. 1.18. What is the ratio of the Balance of Payment (as % of service imports) of Fragile and conflict affected situations in 2008 to that in 2012?
Your answer should be compact. 0.94. What is the ratio of the Balance of Payment (as % of service imports) of Liberia in 2008 to that in 2012?
Offer a very short reply. 1.11. What is the ratio of the Balance of Payment (as % of service imports) of Venezuela in 2008 to that in 2012?
Offer a terse response. 1.08. What is the ratio of the Balance of Payment (as % of service imports) of Fragile and conflict affected situations in 2009 to that in 2010?
Your answer should be very brief. 1.01. What is the ratio of the Balance of Payment (as % of service imports) in Liberia in 2009 to that in 2010?
Your answer should be very brief. 0.63. What is the ratio of the Balance of Payment (as % of service imports) of Venezuela in 2009 to that in 2010?
Keep it short and to the point. 1.12. What is the ratio of the Balance of Payment (as % of service imports) in Fragile and conflict affected situations in 2009 to that in 2011?
Keep it short and to the point. 1.04. What is the ratio of the Balance of Payment (as % of service imports) in Liberia in 2009 to that in 2011?
Offer a very short reply. 0.9. What is the ratio of the Balance of Payment (as % of service imports) in Venezuela in 2009 to that in 2011?
Ensure brevity in your answer.  1.08. What is the ratio of the Balance of Payment (as % of service imports) in Liberia in 2009 to that in 2012?
Give a very brief answer. 0.5. What is the ratio of the Balance of Payment (as % of service imports) in Venezuela in 2009 to that in 2012?
Provide a succinct answer. 0.98. What is the ratio of the Balance of Payment (as % of service imports) of Fragile and conflict affected situations in 2010 to that in 2011?
Your answer should be compact. 1.03. What is the ratio of the Balance of Payment (as % of service imports) in Liberia in 2010 to that in 2011?
Ensure brevity in your answer.  1.42. What is the ratio of the Balance of Payment (as % of service imports) of Venezuela in 2010 to that in 2011?
Keep it short and to the point. 0.96. What is the ratio of the Balance of Payment (as % of service imports) in Fragile and conflict affected situations in 2010 to that in 2012?
Give a very brief answer. 0.93. What is the ratio of the Balance of Payment (as % of service imports) in Liberia in 2010 to that in 2012?
Make the answer very short. 0.8. What is the ratio of the Balance of Payment (as % of service imports) of Venezuela in 2010 to that in 2012?
Offer a very short reply. 0.88. What is the ratio of the Balance of Payment (as % of service imports) of Fragile and conflict affected situations in 2011 to that in 2012?
Your response must be concise. 0.91. What is the ratio of the Balance of Payment (as % of service imports) in Liberia in 2011 to that in 2012?
Offer a very short reply. 0.56. What is the ratio of the Balance of Payment (as % of service imports) of Venezuela in 2011 to that in 2012?
Make the answer very short. 0.91. What is the difference between the highest and the second highest Balance of Payment (as % of service imports) in Fragile and conflict affected situations?
Offer a terse response. 0.89. What is the difference between the highest and the second highest Balance of Payment (as % of service imports) in Liberia?
Provide a succinct answer. 1.66. What is the difference between the highest and the second highest Balance of Payment (as % of service imports) of Venezuela?
Your answer should be very brief. 3.68. What is the difference between the highest and the lowest Balance of Payment (as % of service imports) of Fragile and conflict affected situations?
Offer a terse response. 4.15. What is the difference between the highest and the lowest Balance of Payment (as % of service imports) in Liberia?
Keep it short and to the point. 8.94. What is the difference between the highest and the lowest Balance of Payment (as % of service imports) in Venezuela?
Provide a short and direct response. 13.47. 